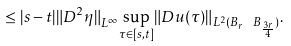<formula> <loc_0><loc_0><loc_500><loc_500>\leq | s - t | { { \| { D ^ { 2 } } \eta \| } _ { L ^ { \infty } } } { \sup _ { \tau \in [ s , t ] } } { { \| D u ( \tau ) \| } _ { { L ^ { 2 } } ( { B _ { r } } \ { B _ { \frac { 3 r } { 4 } } } ) } } .</formula> 